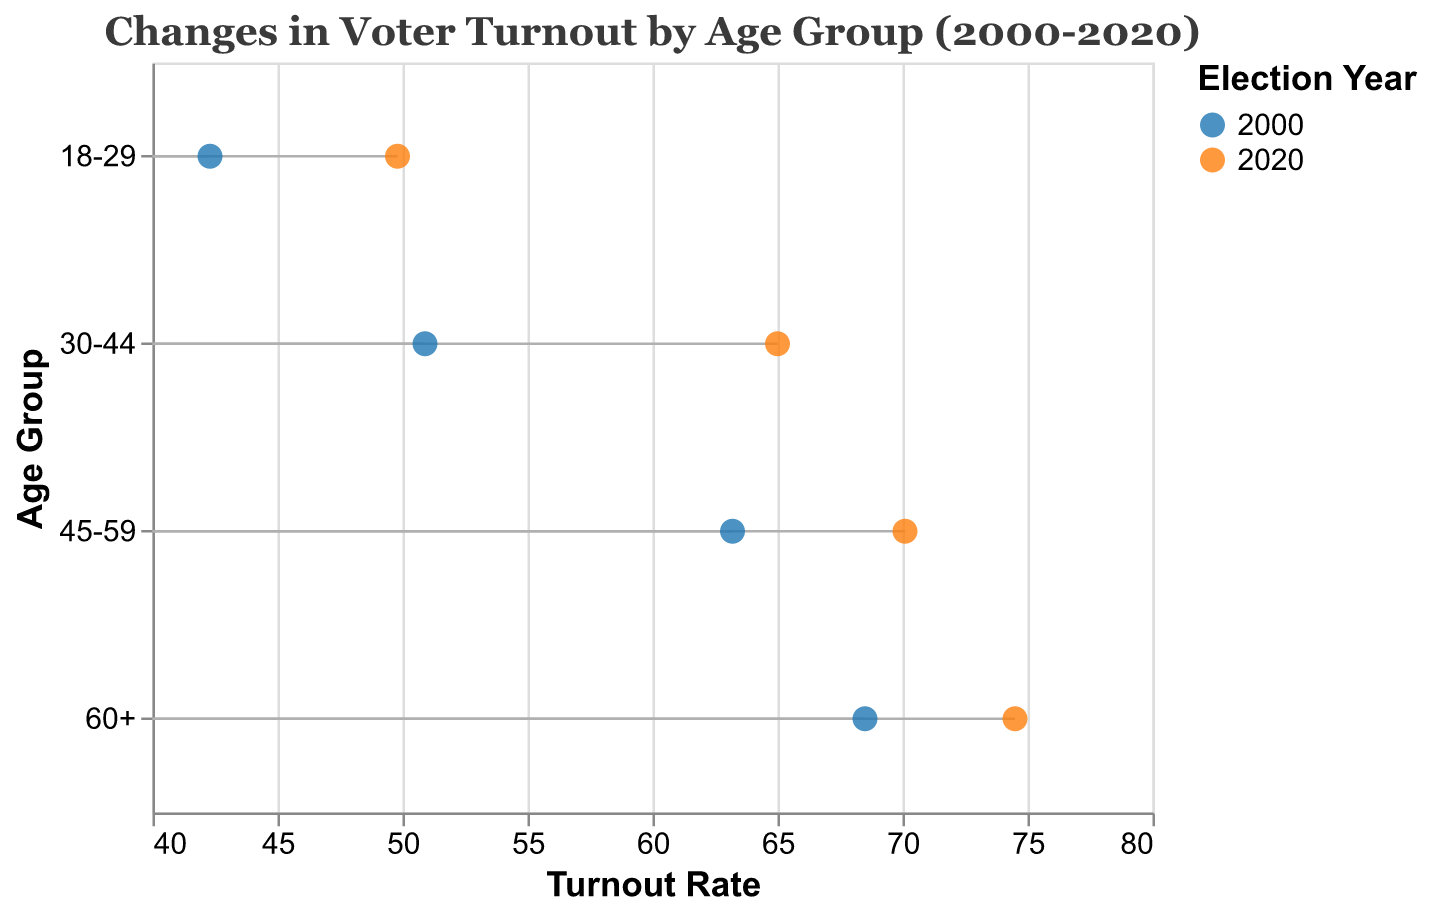What is the title of the figure? The title is located at the top of the figure in a larger font size and should concisely summarize the content of the plot. The title reads "Changes in Voter Turnout by Age Group (2000-2020)"
Answer: Changes in Voter Turnout by Age Group (2000-2020) How many age groups are depicted in the figure? Each unique "Age Group" value corresponds to distinct categories represented on the y-axis. There are four Age Groups: 18-29, 30-44, 45-59, and 60+
Answer: 4 What's the turnout rate for the 60+ age group in the year 2000? The data point for the 60+ age group in 2000 is represented by one of the circles on the plot. The turnout rate next to this point is 68.5.
Answer: 68.5 By how many percentage points did the turnout rate change for the 18-29 age group between 2000 and 2020? The turnout rates for the 18-29 age group were 42.3 in 2000 and 49.8 in 2020. The change is calculated as 49.8 - 42.3.
Answer: 7.5 Which age group saw the highest turnout rate in 2020? Observing the placement of the circles along the x-axis for 2020, each age group's turnout rate can be compared. The 60+ age group has a turnout rate of 74.5, which is the highest.
Answer: 60+ What is the difference in turnout rate between the 30-44 and 45-59 age groups in the year 2000? The turnout rates for these age groups in 2000 are 50.9 and 63.2 respectively. The difference is calculated as 63.2 - 50.9.
Answer: 12.3 Which age group had the most significant increase in voter turnout from 2000 to 2020? To find this, calculate the difference in turnout rates between 2000 and 2020 for each age group and compare them. The 30-44 age group increased from 50.9 to 65.0, an increase of 14.1, which is the highest increase.
Answer: 30-44 Was there any age group for which voter turnout decreased from 2000 to 2020? By observing the movement of the circles from 2000 to 2020 for each age group, we notice that every age group shows an increase, thus no decreases are evident.
Answer: No How much higher was the voter turnout rate for the 45-59 age group compared to the 18-29 age group in 2020? By comparing the turnout rates for these two groups in 2020, the 45-59 age group has a rate of 70.1 and the 18-29 group has a rate of 49.8. The difference is calculated as 70.1 - 49.8.
Answer: 20.3 Using the dumbbell plot, what overall trend can be observed about voter turnout across all age groups from 2000 to 2020? By noting the general movement of the circles to the right from 2000 to 2020 for all age groups, an overall increase in voter turnout is observed for all age groups over this period.
Answer: Increase 